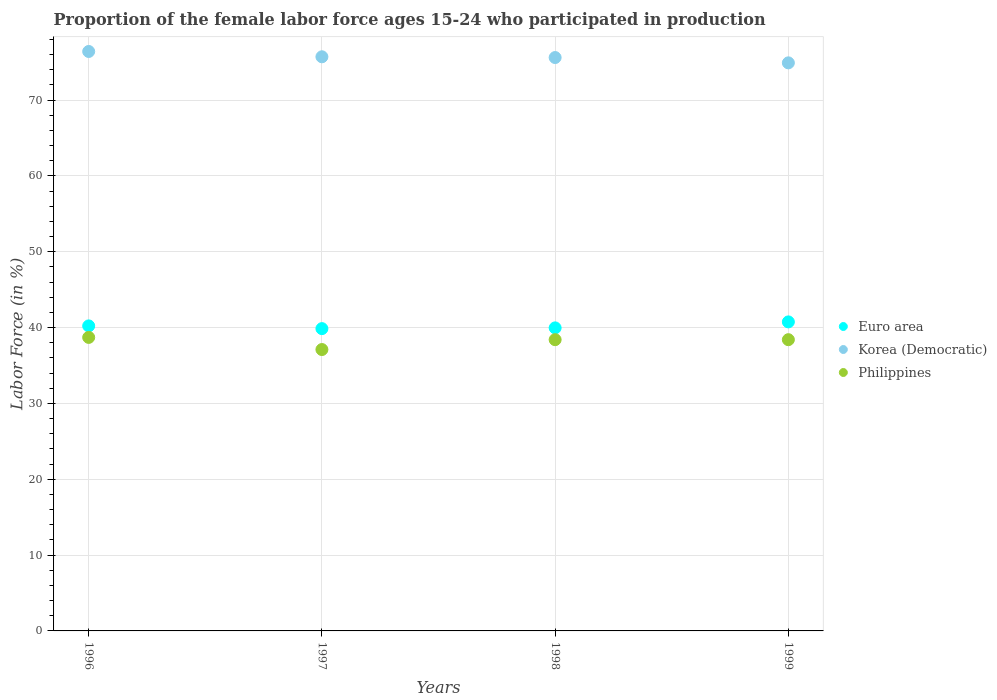Is the number of dotlines equal to the number of legend labels?
Provide a succinct answer. Yes. What is the proportion of the female labor force who participated in production in Euro area in 1996?
Your answer should be very brief. 40.22. Across all years, what is the maximum proportion of the female labor force who participated in production in Philippines?
Provide a succinct answer. 38.7. Across all years, what is the minimum proportion of the female labor force who participated in production in Philippines?
Your response must be concise. 37.1. In which year was the proportion of the female labor force who participated in production in Korea (Democratic) minimum?
Your answer should be compact. 1999. What is the total proportion of the female labor force who participated in production in Euro area in the graph?
Your answer should be very brief. 160.78. What is the difference between the proportion of the female labor force who participated in production in Euro area in 1997 and that in 1998?
Keep it short and to the point. -0.1. What is the difference between the proportion of the female labor force who participated in production in Euro area in 1997 and the proportion of the female labor force who participated in production in Korea (Democratic) in 1999?
Offer a very short reply. -35.04. What is the average proportion of the female labor force who participated in production in Philippines per year?
Give a very brief answer. 38.15. In the year 1998, what is the difference between the proportion of the female labor force who participated in production in Euro area and proportion of the female labor force who participated in production in Philippines?
Your answer should be very brief. 1.56. What is the difference between the highest and the second highest proportion of the female labor force who participated in production in Korea (Democratic)?
Your answer should be very brief. 0.7. Is the sum of the proportion of the female labor force who participated in production in Euro area in 1998 and 1999 greater than the maximum proportion of the female labor force who participated in production in Korea (Democratic) across all years?
Make the answer very short. Yes. Does the proportion of the female labor force who participated in production in Philippines monotonically increase over the years?
Make the answer very short. No. Is the proportion of the female labor force who participated in production in Philippines strictly greater than the proportion of the female labor force who participated in production in Euro area over the years?
Ensure brevity in your answer.  No. How many dotlines are there?
Keep it short and to the point. 3. What is the difference between two consecutive major ticks on the Y-axis?
Make the answer very short. 10. Are the values on the major ticks of Y-axis written in scientific E-notation?
Offer a very short reply. No. Does the graph contain any zero values?
Your response must be concise. No. Does the graph contain grids?
Your response must be concise. Yes. Where does the legend appear in the graph?
Your answer should be very brief. Center right. How are the legend labels stacked?
Provide a succinct answer. Vertical. What is the title of the graph?
Keep it short and to the point. Proportion of the female labor force ages 15-24 who participated in production. Does "Brunei Darussalam" appear as one of the legend labels in the graph?
Offer a terse response. No. What is the label or title of the X-axis?
Give a very brief answer. Years. What is the label or title of the Y-axis?
Your answer should be very brief. Labor Force (in %). What is the Labor Force (in %) of Euro area in 1996?
Your answer should be compact. 40.22. What is the Labor Force (in %) of Korea (Democratic) in 1996?
Your answer should be compact. 76.4. What is the Labor Force (in %) of Philippines in 1996?
Make the answer very short. 38.7. What is the Labor Force (in %) in Euro area in 1997?
Keep it short and to the point. 39.86. What is the Labor Force (in %) in Korea (Democratic) in 1997?
Offer a terse response. 75.7. What is the Labor Force (in %) in Philippines in 1997?
Offer a terse response. 37.1. What is the Labor Force (in %) of Euro area in 1998?
Give a very brief answer. 39.96. What is the Labor Force (in %) of Korea (Democratic) in 1998?
Give a very brief answer. 75.6. What is the Labor Force (in %) of Philippines in 1998?
Your response must be concise. 38.4. What is the Labor Force (in %) of Euro area in 1999?
Keep it short and to the point. 40.75. What is the Labor Force (in %) in Korea (Democratic) in 1999?
Ensure brevity in your answer.  74.9. What is the Labor Force (in %) of Philippines in 1999?
Offer a terse response. 38.4. Across all years, what is the maximum Labor Force (in %) in Euro area?
Make the answer very short. 40.75. Across all years, what is the maximum Labor Force (in %) in Korea (Democratic)?
Offer a very short reply. 76.4. Across all years, what is the maximum Labor Force (in %) in Philippines?
Provide a succinct answer. 38.7. Across all years, what is the minimum Labor Force (in %) in Euro area?
Provide a succinct answer. 39.86. Across all years, what is the minimum Labor Force (in %) of Korea (Democratic)?
Your response must be concise. 74.9. Across all years, what is the minimum Labor Force (in %) in Philippines?
Make the answer very short. 37.1. What is the total Labor Force (in %) in Euro area in the graph?
Your response must be concise. 160.78. What is the total Labor Force (in %) in Korea (Democratic) in the graph?
Ensure brevity in your answer.  302.6. What is the total Labor Force (in %) of Philippines in the graph?
Keep it short and to the point. 152.6. What is the difference between the Labor Force (in %) of Euro area in 1996 and that in 1997?
Offer a terse response. 0.36. What is the difference between the Labor Force (in %) in Philippines in 1996 and that in 1997?
Provide a succinct answer. 1.6. What is the difference between the Labor Force (in %) in Euro area in 1996 and that in 1998?
Give a very brief answer. 0.26. What is the difference between the Labor Force (in %) in Philippines in 1996 and that in 1998?
Offer a very short reply. 0.3. What is the difference between the Labor Force (in %) of Euro area in 1996 and that in 1999?
Offer a very short reply. -0.53. What is the difference between the Labor Force (in %) of Korea (Democratic) in 1996 and that in 1999?
Ensure brevity in your answer.  1.5. What is the difference between the Labor Force (in %) in Euro area in 1997 and that in 1998?
Ensure brevity in your answer.  -0.1. What is the difference between the Labor Force (in %) of Euro area in 1997 and that in 1999?
Make the answer very short. -0.89. What is the difference between the Labor Force (in %) of Philippines in 1997 and that in 1999?
Provide a short and direct response. -1.3. What is the difference between the Labor Force (in %) of Euro area in 1998 and that in 1999?
Provide a short and direct response. -0.79. What is the difference between the Labor Force (in %) of Korea (Democratic) in 1998 and that in 1999?
Give a very brief answer. 0.7. What is the difference between the Labor Force (in %) in Philippines in 1998 and that in 1999?
Your response must be concise. 0. What is the difference between the Labor Force (in %) of Euro area in 1996 and the Labor Force (in %) of Korea (Democratic) in 1997?
Your response must be concise. -35.48. What is the difference between the Labor Force (in %) of Euro area in 1996 and the Labor Force (in %) of Philippines in 1997?
Your response must be concise. 3.12. What is the difference between the Labor Force (in %) in Korea (Democratic) in 1996 and the Labor Force (in %) in Philippines in 1997?
Keep it short and to the point. 39.3. What is the difference between the Labor Force (in %) of Euro area in 1996 and the Labor Force (in %) of Korea (Democratic) in 1998?
Provide a short and direct response. -35.38. What is the difference between the Labor Force (in %) in Euro area in 1996 and the Labor Force (in %) in Philippines in 1998?
Provide a short and direct response. 1.82. What is the difference between the Labor Force (in %) of Euro area in 1996 and the Labor Force (in %) of Korea (Democratic) in 1999?
Provide a succinct answer. -34.68. What is the difference between the Labor Force (in %) in Euro area in 1996 and the Labor Force (in %) in Philippines in 1999?
Give a very brief answer. 1.82. What is the difference between the Labor Force (in %) of Korea (Democratic) in 1996 and the Labor Force (in %) of Philippines in 1999?
Keep it short and to the point. 38. What is the difference between the Labor Force (in %) of Euro area in 1997 and the Labor Force (in %) of Korea (Democratic) in 1998?
Your answer should be very brief. -35.74. What is the difference between the Labor Force (in %) in Euro area in 1997 and the Labor Force (in %) in Philippines in 1998?
Keep it short and to the point. 1.46. What is the difference between the Labor Force (in %) in Korea (Democratic) in 1997 and the Labor Force (in %) in Philippines in 1998?
Ensure brevity in your answer.  37.3. What is the difference between the Labor Force (in %) of Euro area in 1997 and the Labor Force (in %) of Korea (Democratic) in 1999?
Offer a terse response. -35.04. What is the difference between the Labor Force (in %) in Euro area in 1997 and the Labor Force (in %) in Philippines in 1999?
Give a very brief answer. 1.46. What is the difference between the Labor Force (in %) in Korea (Democratic) in 1997 and the Labor Force (in %) in Philippines in 1999?
Your answer should be very brief. 37.3. What is the difference between the Labor Force (in %) of Euro area in 1998 and the Labor Force (in %) of Korea (Democratic) in 1999?
Provide a short and direct response. -34.94. What is the difference between the Labor Force (in %) of Euro area in 1998 and the Labor Force (in %) of Philippines in 1999?
Provide a short and direct response. 1.56. What is the difference between the Labor Force (in %) in Korea (Democratic) in 1998 and the Labor Force (in %) in Philippines in 1999?
Your response must be concise. 37.2. What is the average Labor Force (in %) in Euro area per year?
Ensure brevity in your answer.  40.19. What is the average Labor Force (in %) in Korea (Democratic) per year?
Give a very brief answer. 75.65. What is the average Labor Force (in %) in Philippines per year?
Offer a terse response. 38.15. In the year 1996, what is the difference between the Labor Force (in %) in Euro area and Labor Force (in %) in Korea (Democratic)?
Make the answer very short. -36.18. In the year 1996, what is the difference between the Labor Force (in %) of Euro area and Labor Force (in %) of Philippines?
Provide a short and direct response. 1.52. In the year 1996, what is the difference between the Labor Force (in %) of Korea (Democratic) and Labor Force (in %) of Philippines?
Provide a succinct answer. 37.7. In the year 1997, what is the difference between the Labor Force (in %) in Euro area and Labor Force (in %) in Korea (Democratic)?
Offer a terse response. -35.84. In the year 1997, what is the difference between the Labor Force (in %) of Euro area and Labor Force (in %) of Philippines?
Offer a very short reply. 2.76. In the year 1997, what is the difference between the Labor Force (in %) in Korea (Democratic) and Labor Force (in %) in Philippines?
Offer a terse response. 38.6. In the year 1998, what is the difference between the Labor Force (in %) in Euro area and Labor Force (in %) in Korea (Democratic)?
Provide a short and direct response. -35.64. In the year 1998, what is the difference between the Labor Force (in %) of Euro area and Labor Force (in %) of Philippines?
Make the answer very short. 1.56. In the year 1998, what is the difference between the Labor Force (in %) in Korea (Democratic) and Labor Force (in %) in Philippines?
Your answer should be compact. 37.2. In the year 1999, what is the difference between the Labor Force (in %) of Euro area and Labor Force (in %) of Korea (Democratic)?
Your answer should be compact. -34.15. In the year 1999, what is the difference between the Labor Force (in %) in Euro area and Labor Force (in %) in Philippines?
Provide a succinct answer. 2.35. In the year 1999, what is the difference between the Labor Force (in %) of Korea (Democratic) and Labor Force (in %) of Philippines?
Your answer should be compact. 36.5. What is the ratio of the Labor Force (in %) in Korea (Democratic) in 1996 to that in 1997?
Give a very brief answer. 1.01. What is the ratio of the Labor Force (in %) of Philippines in 1996 to that in 1997?
Provide a short and direct response. 1.04. What is the ratio of the Labor Force (in %) in Korea (Democratic) in 1996 to that in 1998?
Offer a terse response. 1.01. What is the ratio of the Labor Force (in %) of Euro area in 1996 to that in 1999?
Offer a terse response. 0.99. What is the ratio of the Labor Force (in %) of Korea (Democratic) in 1996 to that in 1999?
Provide a succinct answer. 1.02. What is the ratio of the Labor Force (in %) of Philippines in 1996 to that in 1999?
Your answer should be compact. 1.01. What is the ratio of the Labor Force (in %) in Philippines in 1997 to that in 1998?
Give a very brief answer. 0.97. What is the ratio of the Labor Force (in %) in Euro area in 1997 to that in 1999?
Keep it short and to the point. 0.98. What is the ratio of the Labor Force (in %) of Korea (Democratic) in 1997 to that in 1999?
Offer a very short reply. 1.01. What is the ratio of the Labor Force (in %) in Philippines in 1997 to that in 1999?
Offer a terse response. 0.97. What is the ratio of the Labor Force (in %) of Euro area in 1998 to that in 1999?
Ensure brevity in your answer.  0.98. What is the ratio of the Labor Force (in %) in Korea (Democratic) in 1998 to that in 1999?
Keep it short and to the point. 1.01. What is the difference between the highest and the second highest Labor Force (in %) of Euro area?
Ensure brevity in your answer.  0.53. What is the difference between the highest and the lowest Labor Force (in %) of Euro area?
Your answer should be very brief. 0.89. What is the difference between the highest and the lowest Labor Force (in %) in Korea (Democratic)?
Make the answer very short. 1.5. What is the difference between the highest and the lowest Labor Force (in %) in Philippines?
Give a very brief answer. 1.6. 